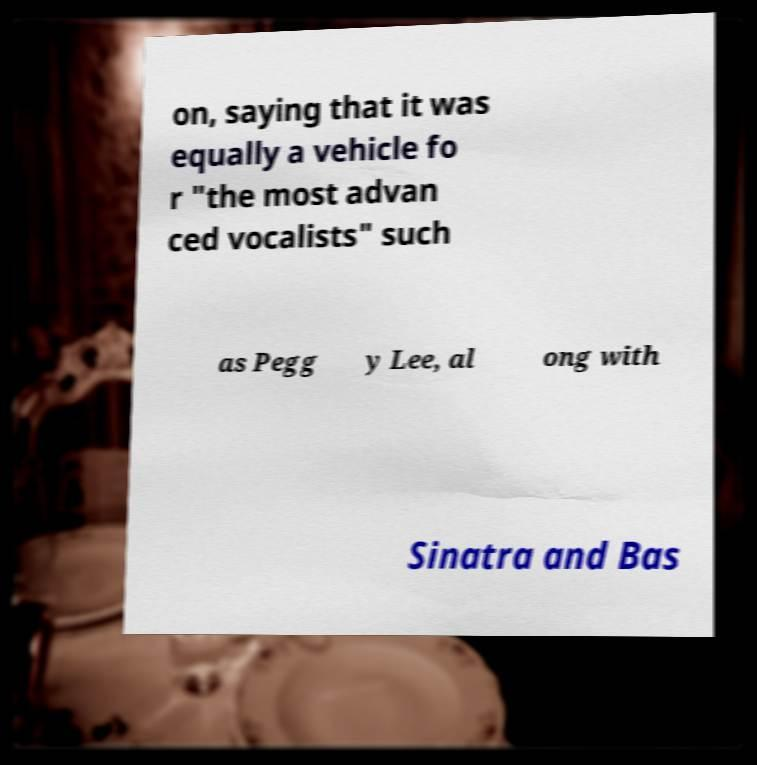For documentation purposes, I need the text within this image transcribed. Could you provide that? on, saying that it was equally a vehicle fo r "the most advan ced vocalists" such as Pegg y Lee, al ong with Sinatra and Bas 